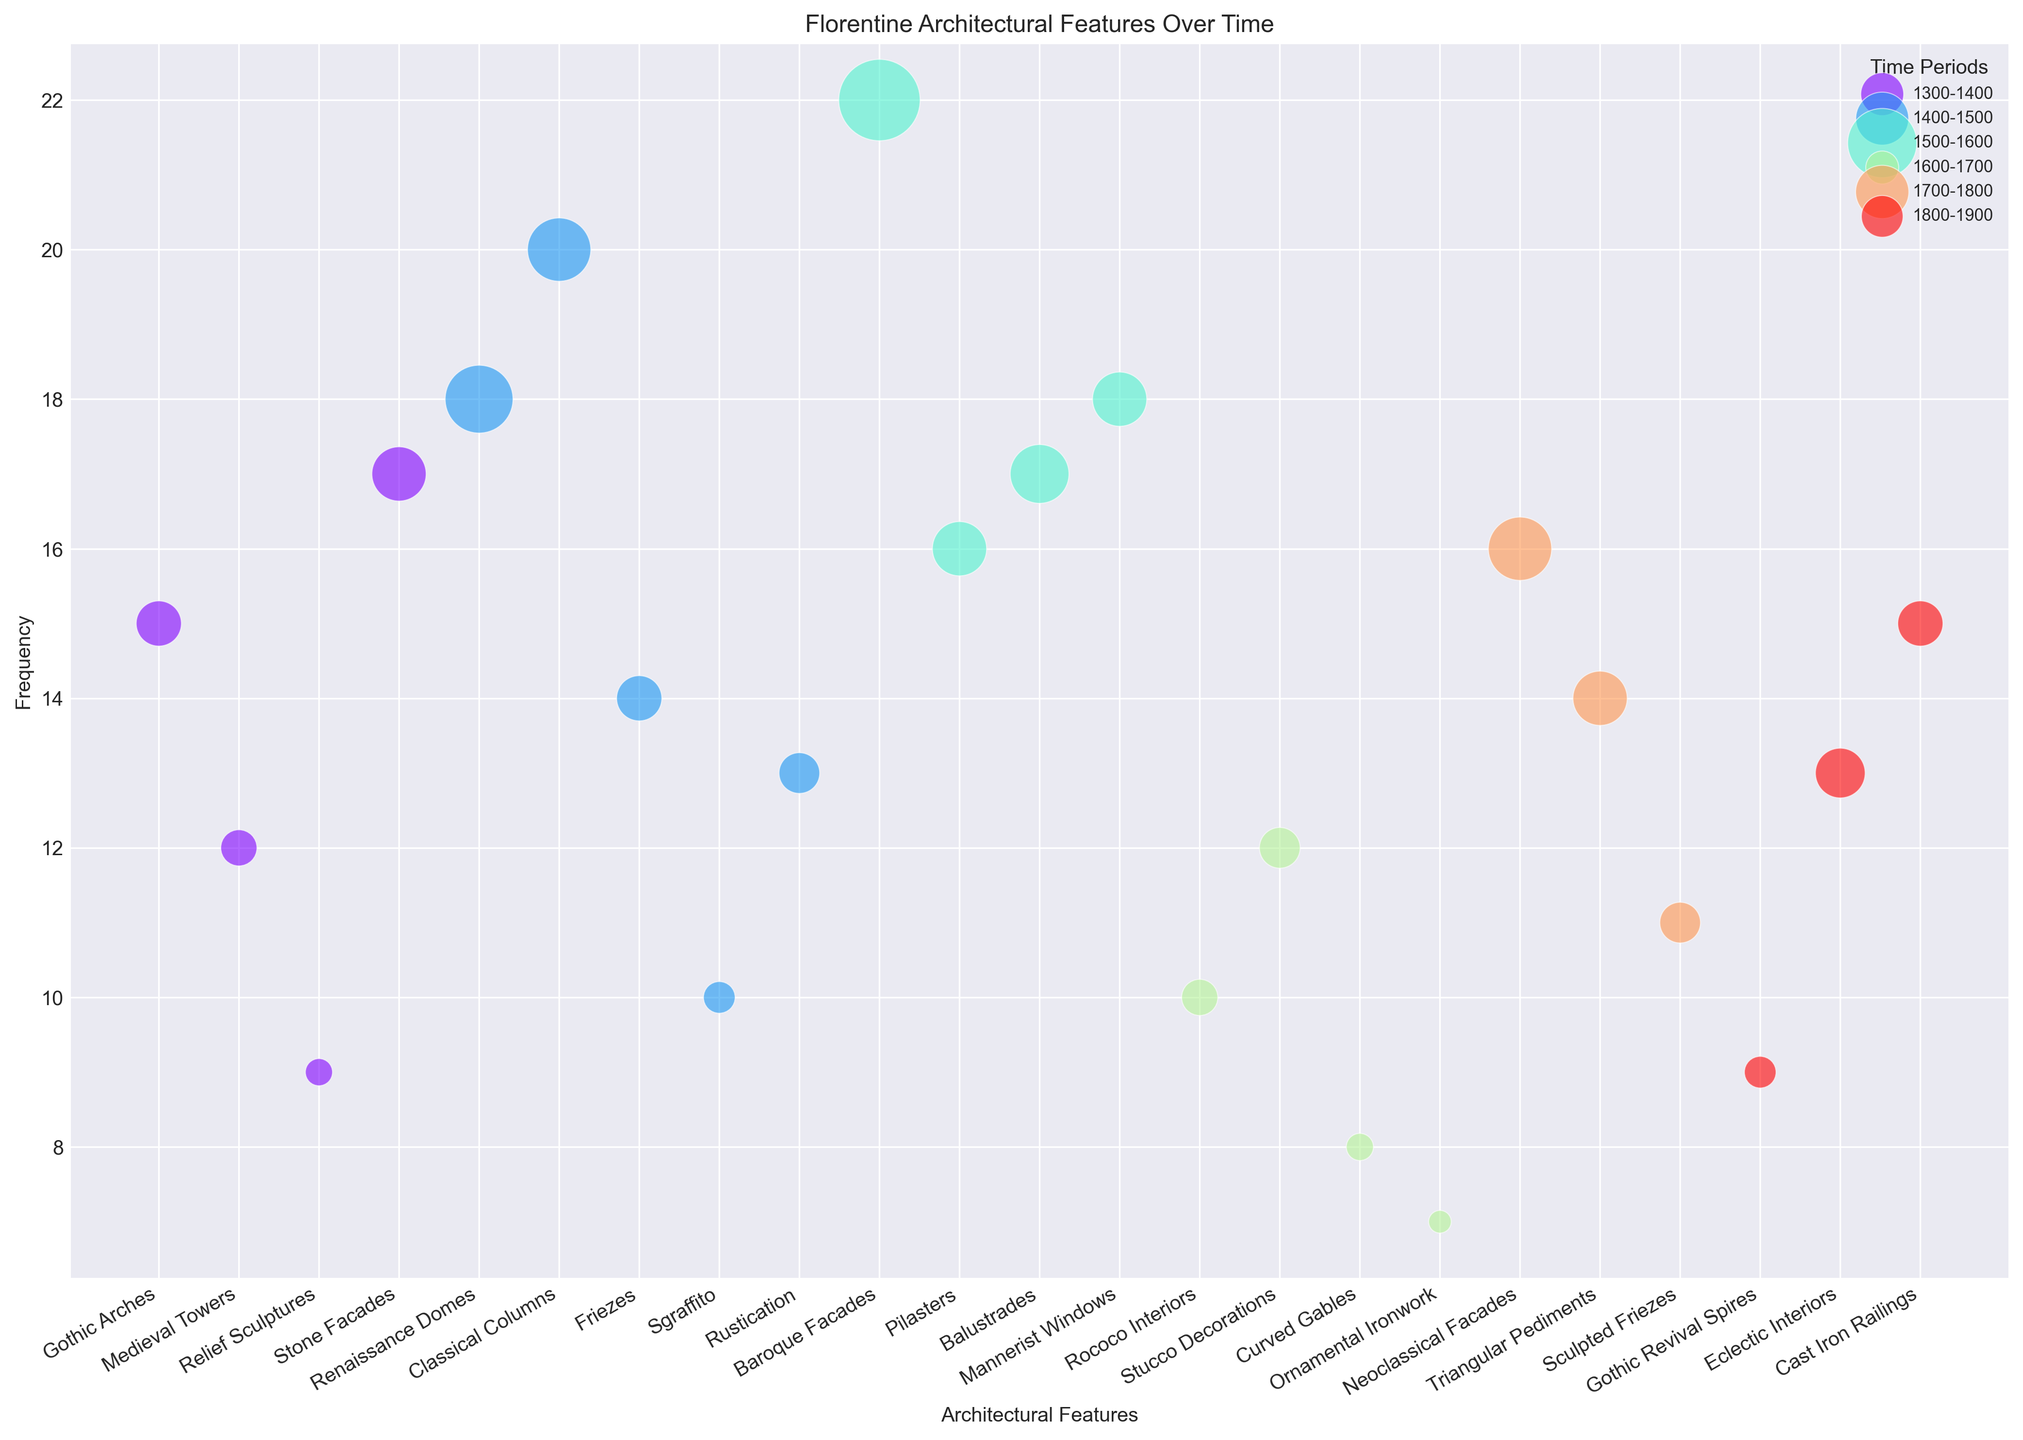What's the most frequently occurring architectural feature from 1400-1500? To find the answer, look at the bubbles labeled with features from the period 1400-1500 and compare their positions on the vertical axis (Frequency). The tallest bubble represents the feature with the highest frequency.
Answer: Classical Columns Which period features the least frequently occurring architectural feature, and what is it? Identify the smallest bubble, which represents the least frequent feature. Observe its color to determine the period. The smallest bubble belongs to the 1600-1700 period and represents Ornamental Ironwork.
Answer: 1600-1700, Ornamental Ironwork Between 1500-1600 and 1600-1700, which has a higher average size of bubbles for their architectural features? Calculate the average bubble size for each period by summing the sizes of features and dividing by the number of features in each period. For 1500-1600: (18+12+13+12)/4 = 13.75. For 1600-1700: (8+9+6+5)/4 = 7.0.
Answer: 1500-1600 Which architectural feature from 1800-1900 has the highest frequency, and how does it compare to the highest in 1300-1400? Locate the bubbles for 1800-1900 and identify the one with the highest placement on the vertical axis, which is Cast Iron Railings with a frequency of 15. Compare it with the highest in 1300-1400, Stone Facades with a frequency of 17.
Answer: Cast Iron Railings, lower than Stone Facades What is the total frequency of Gothic-related architectural features across all periods? Sum the frequencies of all Gothic-related features: Gothic Arches (15 from 1300-1400) and Gothic Revival Spires (9 from 1800-1900). Total frequency = 15 + 9.
Answer: 24 Comparing the average size of features in the 1400-1500 period to those in the 1700-1800 period, which has a larger average size? Calculate the average size for each period: for 1400-1500, sum (15+14+10+7+9)/5 = 11; for 1700-1800, sum (14+12+9)/3 = 11.67. Comparatively, the 1700-1800 period has a slightly larger average size.
Answer: 1700-1800 In which period do the least and most frequent features differ the most in frequency, and what is the difference? For each period, find the difference between the frequencies of the most and least frequent features. The largest difference is for 1500-1600: highest frequency (Baroque Facades, 22) minus lowest (Balustrades, 17) is 22 - 17 = 5.
Answer: 1500-1600, 5 